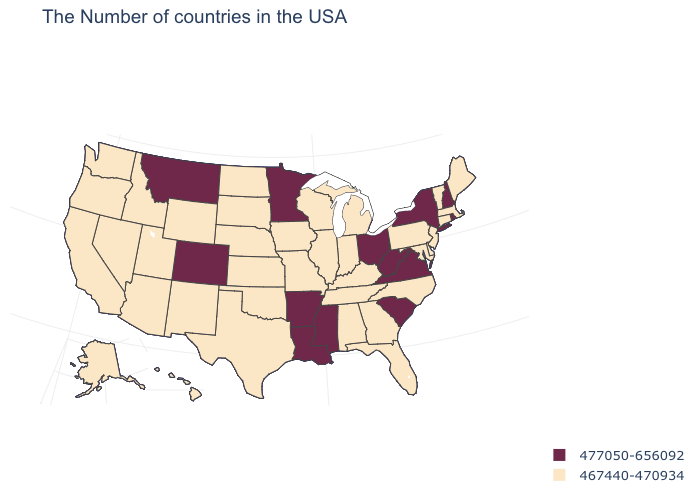Is the legend a continuous bar?
Write a very short answer. No. What is the value of Ohio?
Write a very short answer. 477050-656092. Does the map have missing data?
Short answer required. No. What is the value of Minnesota?
Short answer required. 477050-656092. Among the states that border Wisconsin , does Michigan have the lowest value?
Quick response, please. Yes. What is the value of Delaware?
Keep it brief. 467440-470934. Among the states that border Arizona , which have the lowest value?
Answer briefly. New Mexico, Utah, Nevada, California. How many symbols are there in the legend?
Write a very short answer. 2. Name the states that have a value in the range 477050-656092?
Answer briefly. Rhode Island, New Hampshire, New York, Virginia, South Carolina, West Virginia, Ohio, Mississippi, Louisiana, Arkansas, Minnesota, Colorado, Montana. Does Minnesota have the lowest value in the MidWest?
Write a very short answer. No. Does Texas have the highest value in the South?
Write a very short answer. No. Which states hav the highest value in the MidWest?
Keep it brief. Ohio, Minnesota. Does Minnesota have a higher value than Missouri?
Be succinct. Yes. Name the states that have a value in the range 467440-470934?
Keep it brief. Maine, Massachusetts, Vermont, Connecticut, New Jersey, Delaware, Maryland, Pennsylvania, North Carolina, Florida, Georgia, Michigan, Kentucky, Indiana, Alabama, Tennessee, Wisconsin, Illinois, Missouri, Iowa, Kansas, Nebraska, Oklahoma, Texas, South Dakota, North Dakota, Wyoming, New Mexico, Utah, Arizona, Idaho, Nevada, California, Washington, Oregon, Alaska, Hawaii. 